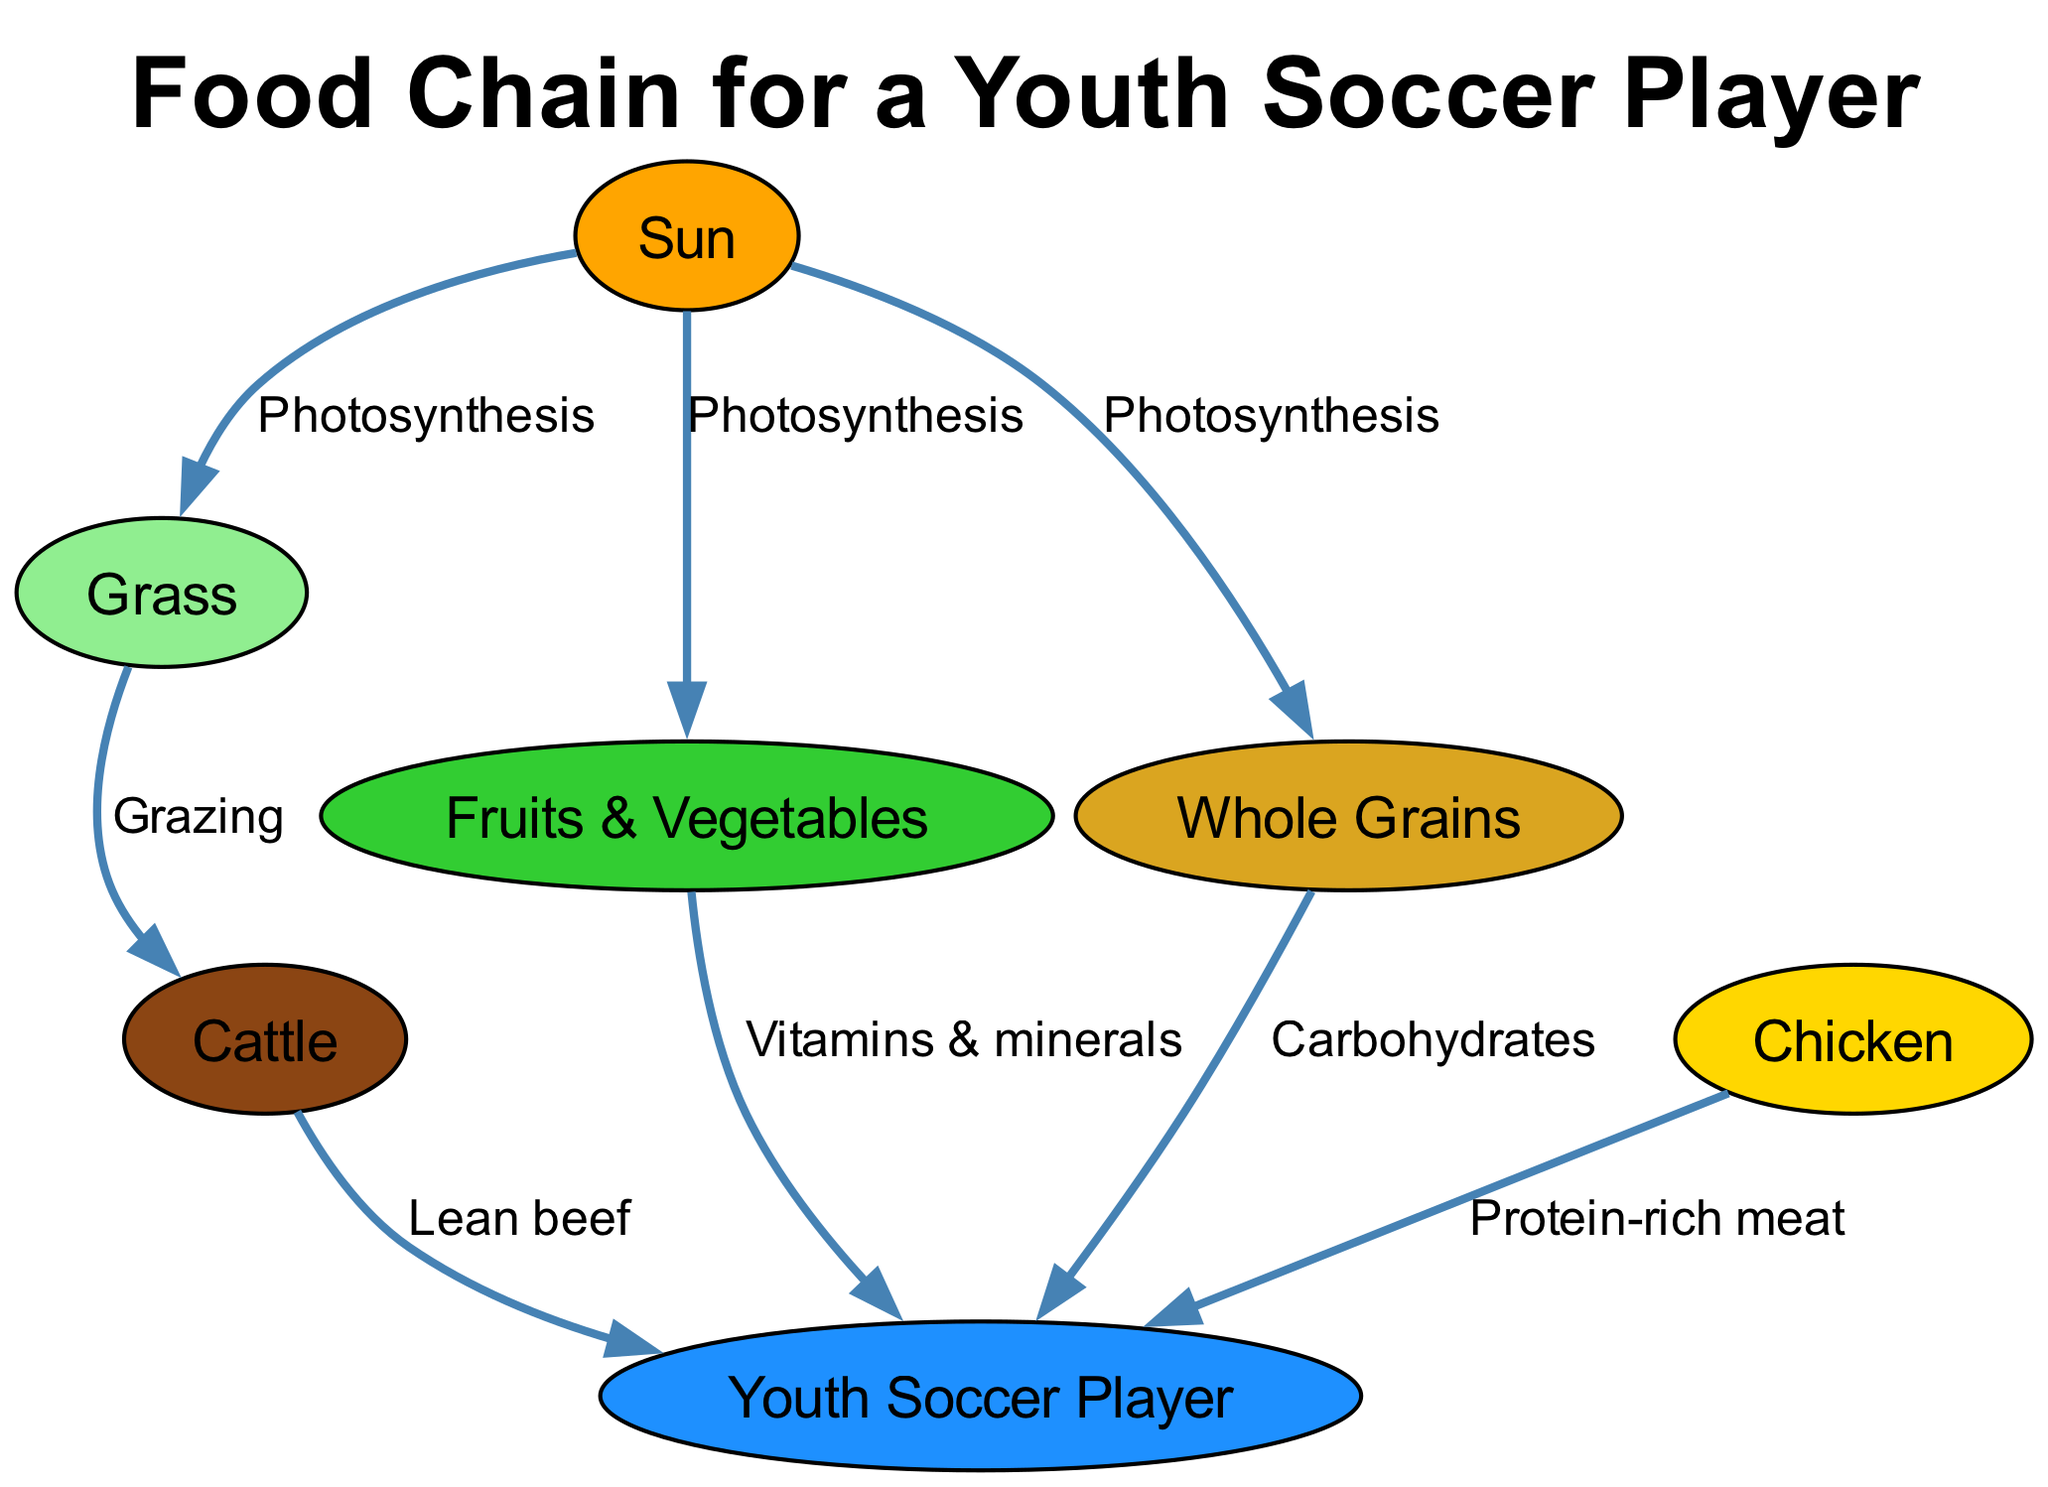What is the primary source of energy in the food chain? The diagram depicts the Sun as the starting point, which is responsible for photosynthesis, providing energy for all following elements.
Answer: Sun How many nodes are present in the food chain diagram? By counting the distinct items represented in the nodes, we find that there are 7: Sun, Grass, Cattle, Chicken, Fruits & Vegetables, Whole Grains, and Youth Soccer Player.
Answer: 7 Which food source provides vitamins and minerals to the youth soccer player? The edge from Fruits & Vegetables to the Youth Soccer Player indicates that this category provides essential nutrients, specifically vitamins and minerals.
Answer: Fruits & Vegetables What is the relationship between Grass and Cattle? The diagram clearly labels the relationship as "Grazing," indicating that Cattle feed on Grass for sustenance.
Answer: Grazing Which two food sources provide protein to the youth soccer player? Analyzing the edges leading to the Youth Soccer Player shows two connections: one from Cattle (Lean beef) and another from Chicken (Protein-rich meat), both confirming sources of protein.
Answer: Cattle and Chicken What do Whole Grains provide to the youth soccer player? The directed edge from Whole Grains to the Youth Soccer Player is labeled as "Carbohydrates," highlighting its role in providing energy.
Answer: Carbohydrates What process do the Sun and Grass primarily share? Both the Sun and Grass are linked through the process of photosynthesis, resulting in energy transfer from the sun to the plant.
Answer: Photosynthesis Which node is directly connected to the Cattle node? The diagram reflects a direct edge from Grass to Cattle, demonstrating that Grass is an immediate food source for Cattle.
Answer: Grass What do Chicken and Cattle have in common regarding their contribution to the youth soccer player's diet? Both Chicken and Cattle provide important protein-rich food sources for the Youth Soccer Player, as indicated by their respective connections leading to this node.
Answer: Protein-rich meat 